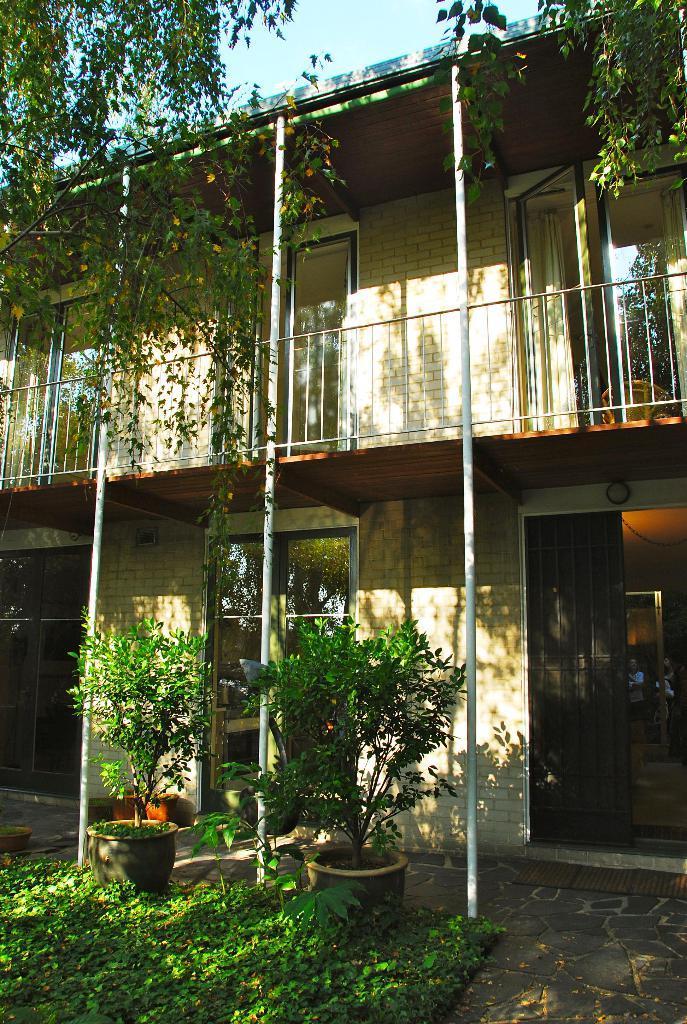Describe this image in one or two sentences. In this image we can see trees, building, house plants and sky. 